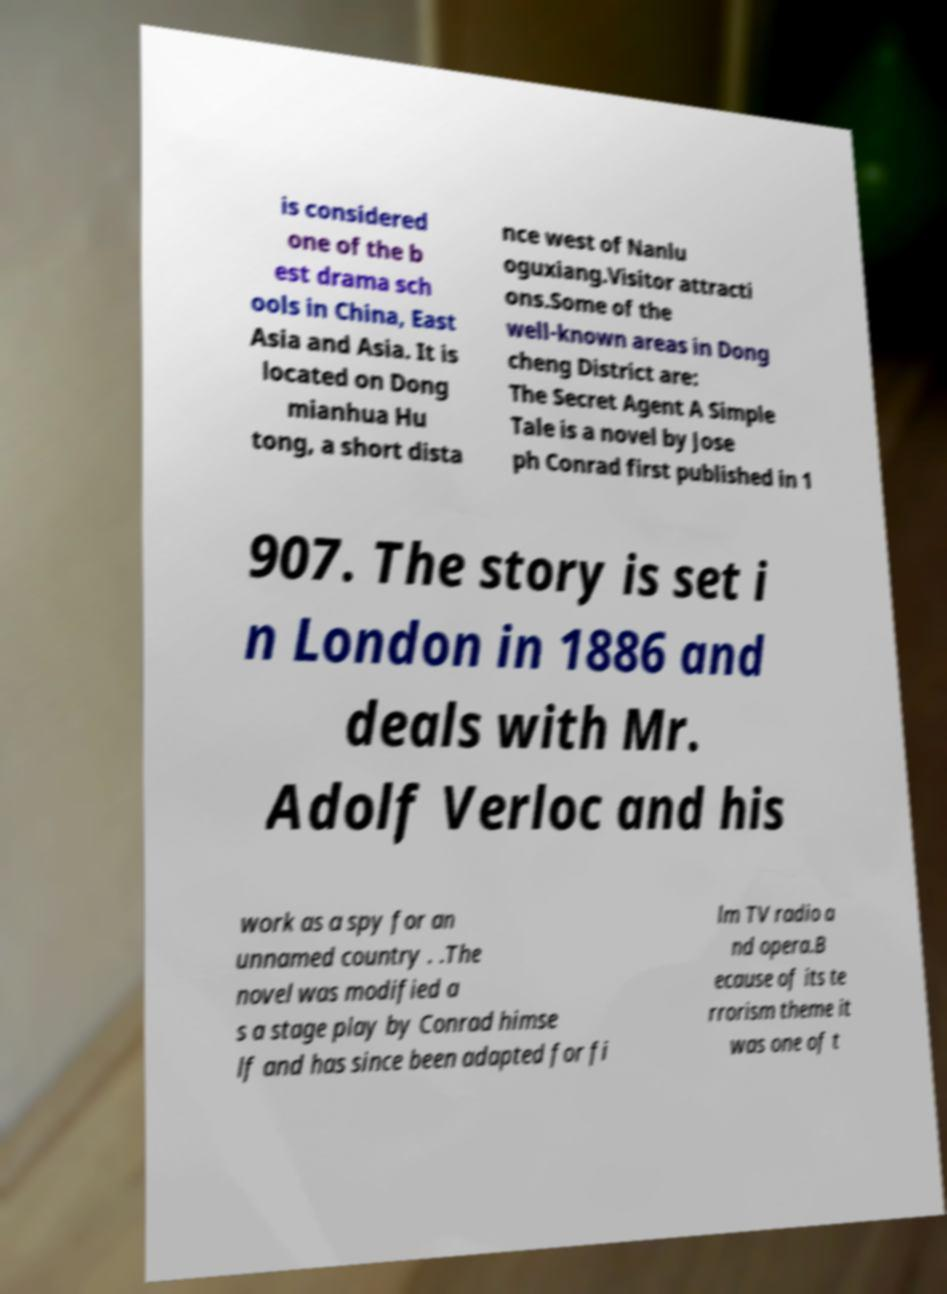Could you extract and type out the text from this image? is considered one of the b est drama sch ools in China, East Asia and Asia. It is located on Dong mianhua Hu tong, a short dista nce west of Nanlu oguxiang.Visitor attracti ons.Some of the well-known areas in Dong cheng District are: The Secret Agent A Simple Tale is a novel by Jose ph Conrad first published in 1 907. The story is set i n London in 1886 and deals with Mr. Adolf Verloc and his work as a spy for an unnamed country . .The novel was modified a s a stage play by Conrad himse lf and has since been adapted for fi lm TV radio a nd opera.B ecause of its te rrorism theme it was one of t 